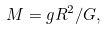<formula> <loc_0><loc_0><loc_500><loc_500>M = g R ^ { 2 } / G ,</formula> 